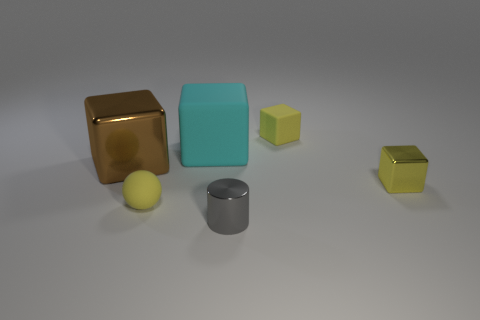What is the material of the large cyan object that is the same shape as the big brown object?
Your answer should be very brief. Rubber. Are there more big metallic blocks on the right side of the tiny shiny cube than big shiny blocks behind the cyan rubber object?
Provide a succinct answer. No. There is a brown object that is the same material as the gray thing; what shape is it?
Give a very brief answer. Cube. Is the number of yellow metal things that are behind the large cyan object greater than the number of large brown blocks?
Your answer should be compact. No. What number of cubes are the same color as the cylinder?
Provide a succinct answer. 0. What number of other objects are the same color as the big metal thing?
Offer a terse response. 0. Is the number of brown cubes greater than the number of big purple metallic things?
Keep it short and to the point. Yes. What is the material of the large cyan block?
Your answer should be compact. Rubber. Does the matte thing right of the gray shiny object have the same size as the tiny ball?
Make the answer very short. Yes. There is a metal cylinder in front of the cyan thing; what is its size?
Ensure brevity in your answer.  Small. 